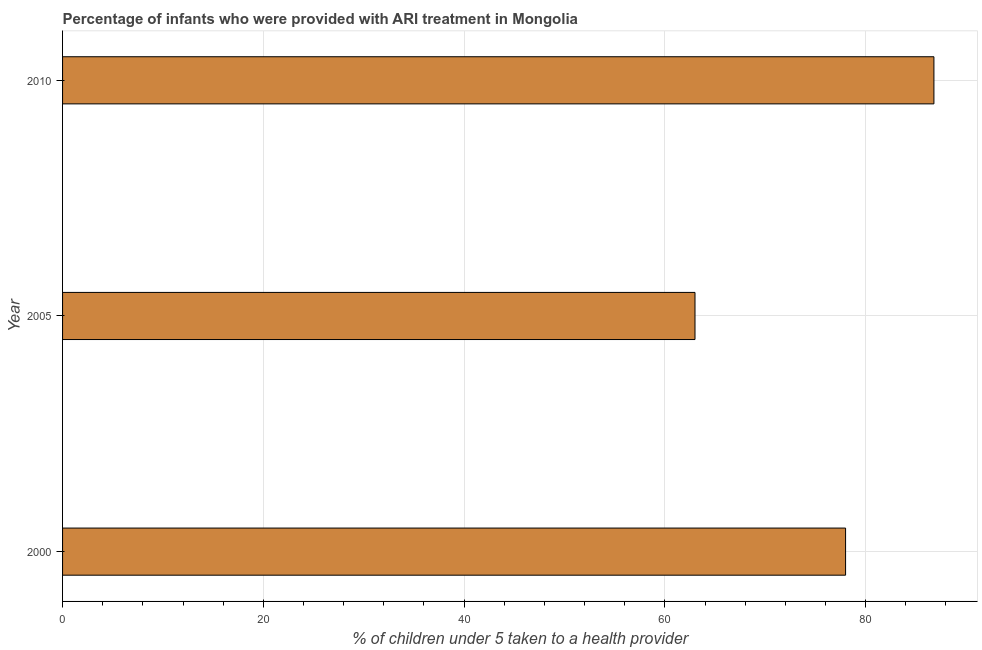What is the title of the graph?
Provide a succinct answer. Percentage of infants who were provided with ARI treatment in Mongolia. What is the label or title of the X-axis?
Give a very brief answer. % of children under 5 taken to a health provider. What is the percentage of children who were provided with ari treatment in 2010?
Offer a very short reply. 86.8. Across all years, what is the maximum percentage of children who were provided with ari treatment?
Make the answer very short. 86.8. What is the sum of the percentage of children who were provided with ari treatment?
Provide a short and direct response. 227.8. What is the difference between the percentage of children who were provided with ari treatment in 2005 and 2010?
Ensure brevity in your answer.  -23.8. What is the average percentage of children who were provided with ari treatment per year?
Your response must be concise. 75.93. What is the median percentage of children who were provided with ari treatment?
Keep it short and to the point. 78. In how many years, is the percentage of children who were provided with ari treatment greater than 84 %?
Offer a terse response. 1. Do a majority of the years between 2000 and 2010 (inclusive) have percentage of children who were provided with ari treatment greater than 76 %?
Ensure brevity in your answer.  Yes. What is the ratio of the percentage of children who were provided with ari treatment in 2000 to that in 2010?
Keep it short and to the point. 0.9. Is the percentage of children who were provided with ari treatment in 2000 less than that in 2005?
Provide a succinct answer. No. Is the difference between the percentage of children who were provided with ari treatment in 2000 and 2010 greater than the difference between any two years?
Your answer should be compact. No. What is the difference between the highest and the second highest percentage of children who were provided with ari treatment?
Make the answer very short. 8.8. What is the difference between the highest and the lowest percentage of children who were provided with ari treatment?
Ensure brevity in your answer.  23.8. Are all the bars in the graph horizontal?
Your answer should be compact. Yes. How many years are there in the graph?
Keep it short and to the point. 3. What is the difference between two consecutive major ticks on the X-axis?
Ensure brevity in your answer.  20. Are the values on the major ticks of X-axis written in scientific E-notation?
Ensure brevity in your answer.  No. What is the % of children under 5 taken to a health provider of 2010?
Keep it short and to the point. 86.8. What is the difference between the % of children under 5 taken to a health provider in 2000 and 2005?
Your answer should be compact. 15. What is the difference between the % of children under 5 taken to a health provider in 2005 and 2010?
Give a very brief answer. -23.8. What is the ratio of the % of children under 5 taken to a health provider in 2000 to that in 2005?
Offer a very short reply. 1.24. What is the ratio of the % of children under 5 taken to a health provider in 2000 to that in 2010?
Provide a short and direct response. 0.9. What is the ratio of the % of children under 5 taken to a health provider in 2005 to that in 2010?
Make the answer very short. 0.73. 